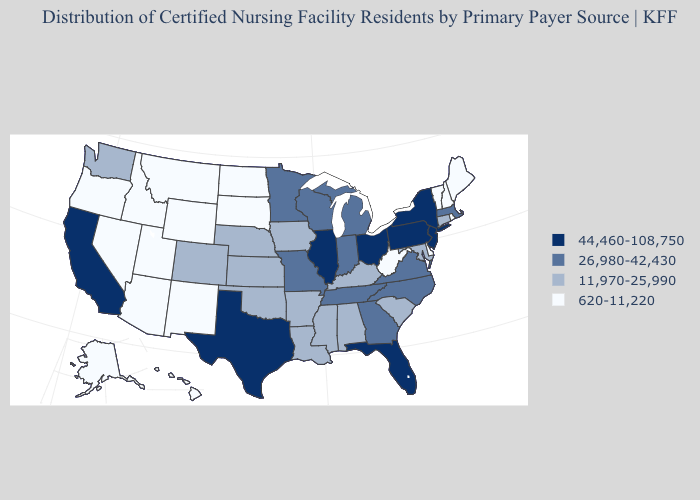What is the value of New York?
Short answer required. 44,460-108,750. Name the states that have a value in the range 44,460-108,750?
Concise answer only. California, Florida, Illinois, New Jersey, New York, Ohio, Pennsylvania, Texas. Among the states that border Georgia , which have the highest value?
Write a very short answer. Florida. Which states have the lowest value in the West?
Concise answer only. Alaska, Arizona, Hawaii, Idaho, Montana, Nevada, New Mexico, Oregon, Utah, Wyoming. What is the value of New Mexico?
Keep it brief. 620-11,220. What is the value of Arizona?
Write a very short answer. 620-11,220. What is the value of West Virginia?
Answer briefly. 620-11,220. Does the first symbol in the legend represent the smallest category?
Write a very short answer. No. What is the lowest value in the Northeast?
Short answer required. 620-11,220. What is the value of Iowa?
Short answer required. 11,970-25,990. Does Maine have a lower value than Hawaii?
Quick response, please. No. What is the lowest value in states that border South Carolina?
Concise answer only. 26,980-42,430. What is the lowest value in states that border Minnesota?
Keep it brief. 620-11,220. Does Delaware have the lowest value in the South?
Concise answer only. Yes. What is the lowest value in the USA?
Write a very short answer. 620-11,220. 